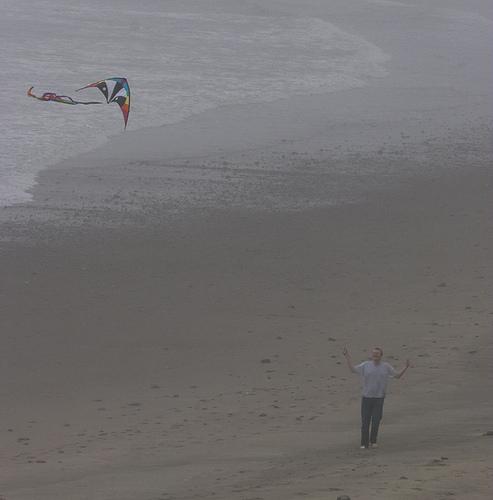Is this person wearing a swimsuit?
Keep it brief. No. Is the man flying the kite leaving footprints in the sand?
Give a very brief answer. Yes. What color is the water?
Write a very short answer. White. Is the man using both hands to fly the kite?
Concise answer only. Yes. Is it sunny outside?
Concise answer only. No. What is the man wearing?
Concise answer only. Casual attire. How many people on the beach?
Write a very short answer. 1. What is in his arm?
Concise answer only. Kite. 